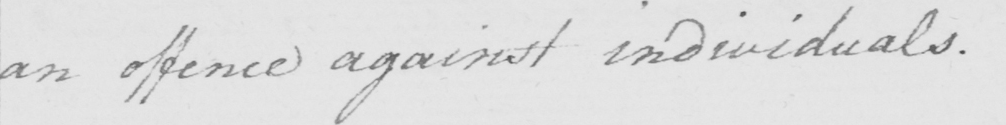Please provide the text content of this handwritten line. an offence against individuals . 